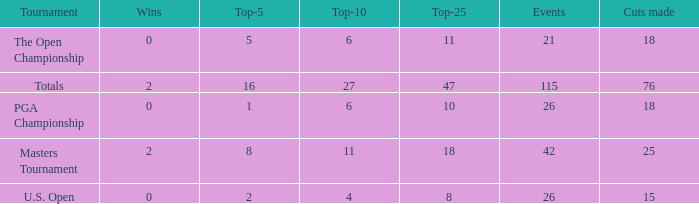How many average cuts made when 11 is the Top-10? 25.0. 